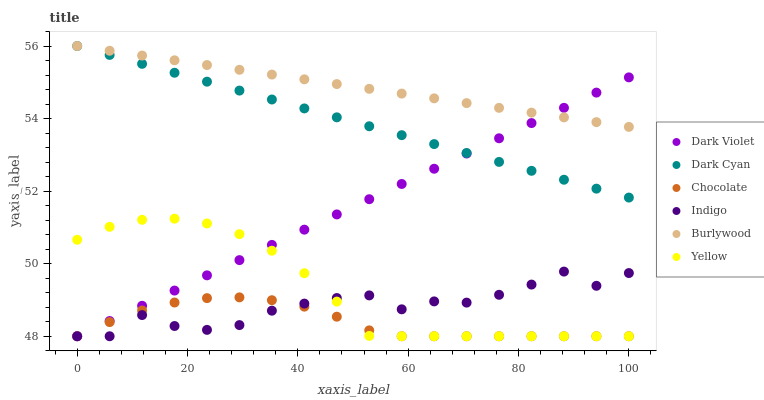Does Chocolate have the minimum area under the curve?
Answer yes or no. Yes. Does Burlywood have the maximum area under the curve?
Answer yes or no. Yes. Does Yellow have the minimum area under the curve?
Answer yes or no. No. Does Yellow have the maximum area under the curve?
Answer yes or no. No. Is Burlywood the smoothest?
Answer yes or no. Yes. Is Indigo the roughest?
Answer yes or no. Yes. Is Yellow the smoothest?
Answer yes or no. No. Is Yellow the roughest?
Answer yes or no. No. Does Indigo have the lowest value?
Answer yes or no. Yes. Does Burlywood have the lowest value?
Answer yes or no. No. Does Dark Cyan have the highest value?
Answer yes or no. Yes. Does Yellow have the highest value?
Answer yes or no. No. Is Chocolate less than Dark Cyan?
Answer yes or no. Yes. Is Burlywood greater than Indigo?
Answer yes or no. Yes. Does Indigo intersect Chocolate?
Answer yes or no. Yes. Is Indigo less than Chocolate?
Answer yes or no. No. Is Indigo greater than Chocolate?
Answer yes or no. No. Does Chocolate intersect Dark Cyan?
Answer yes or no. No. 